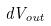<formula> <loc_0><loc_0><loc_500><loc_500>d V _ { o u t }</formula> 